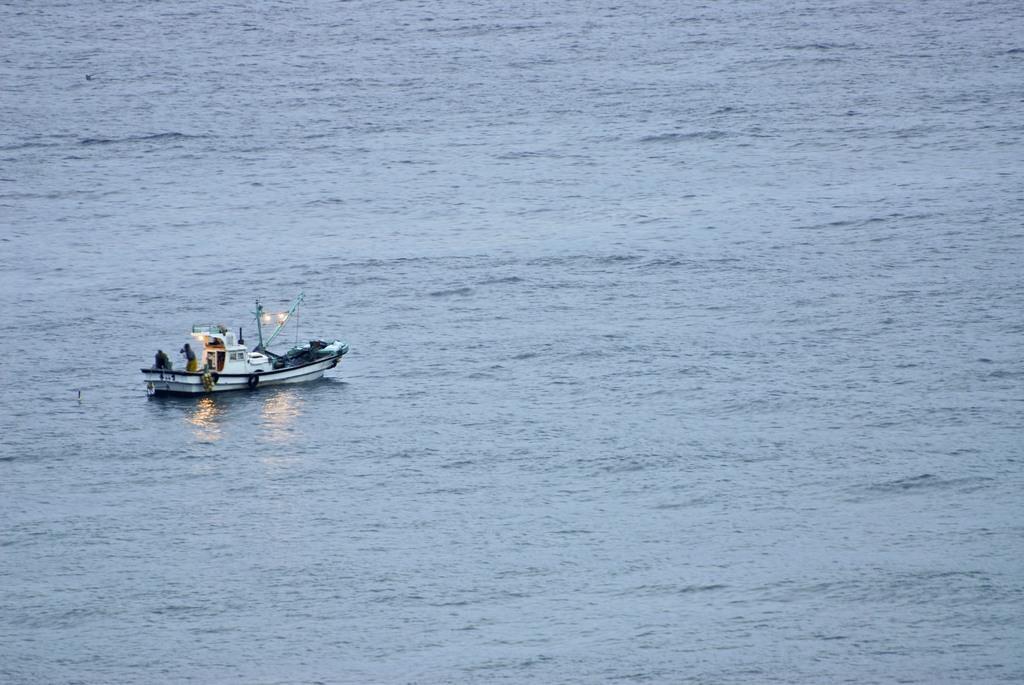Describe this image in one or two sentences. In this picture there is water. Towards left there is a boat, in the boat there are two persons. 